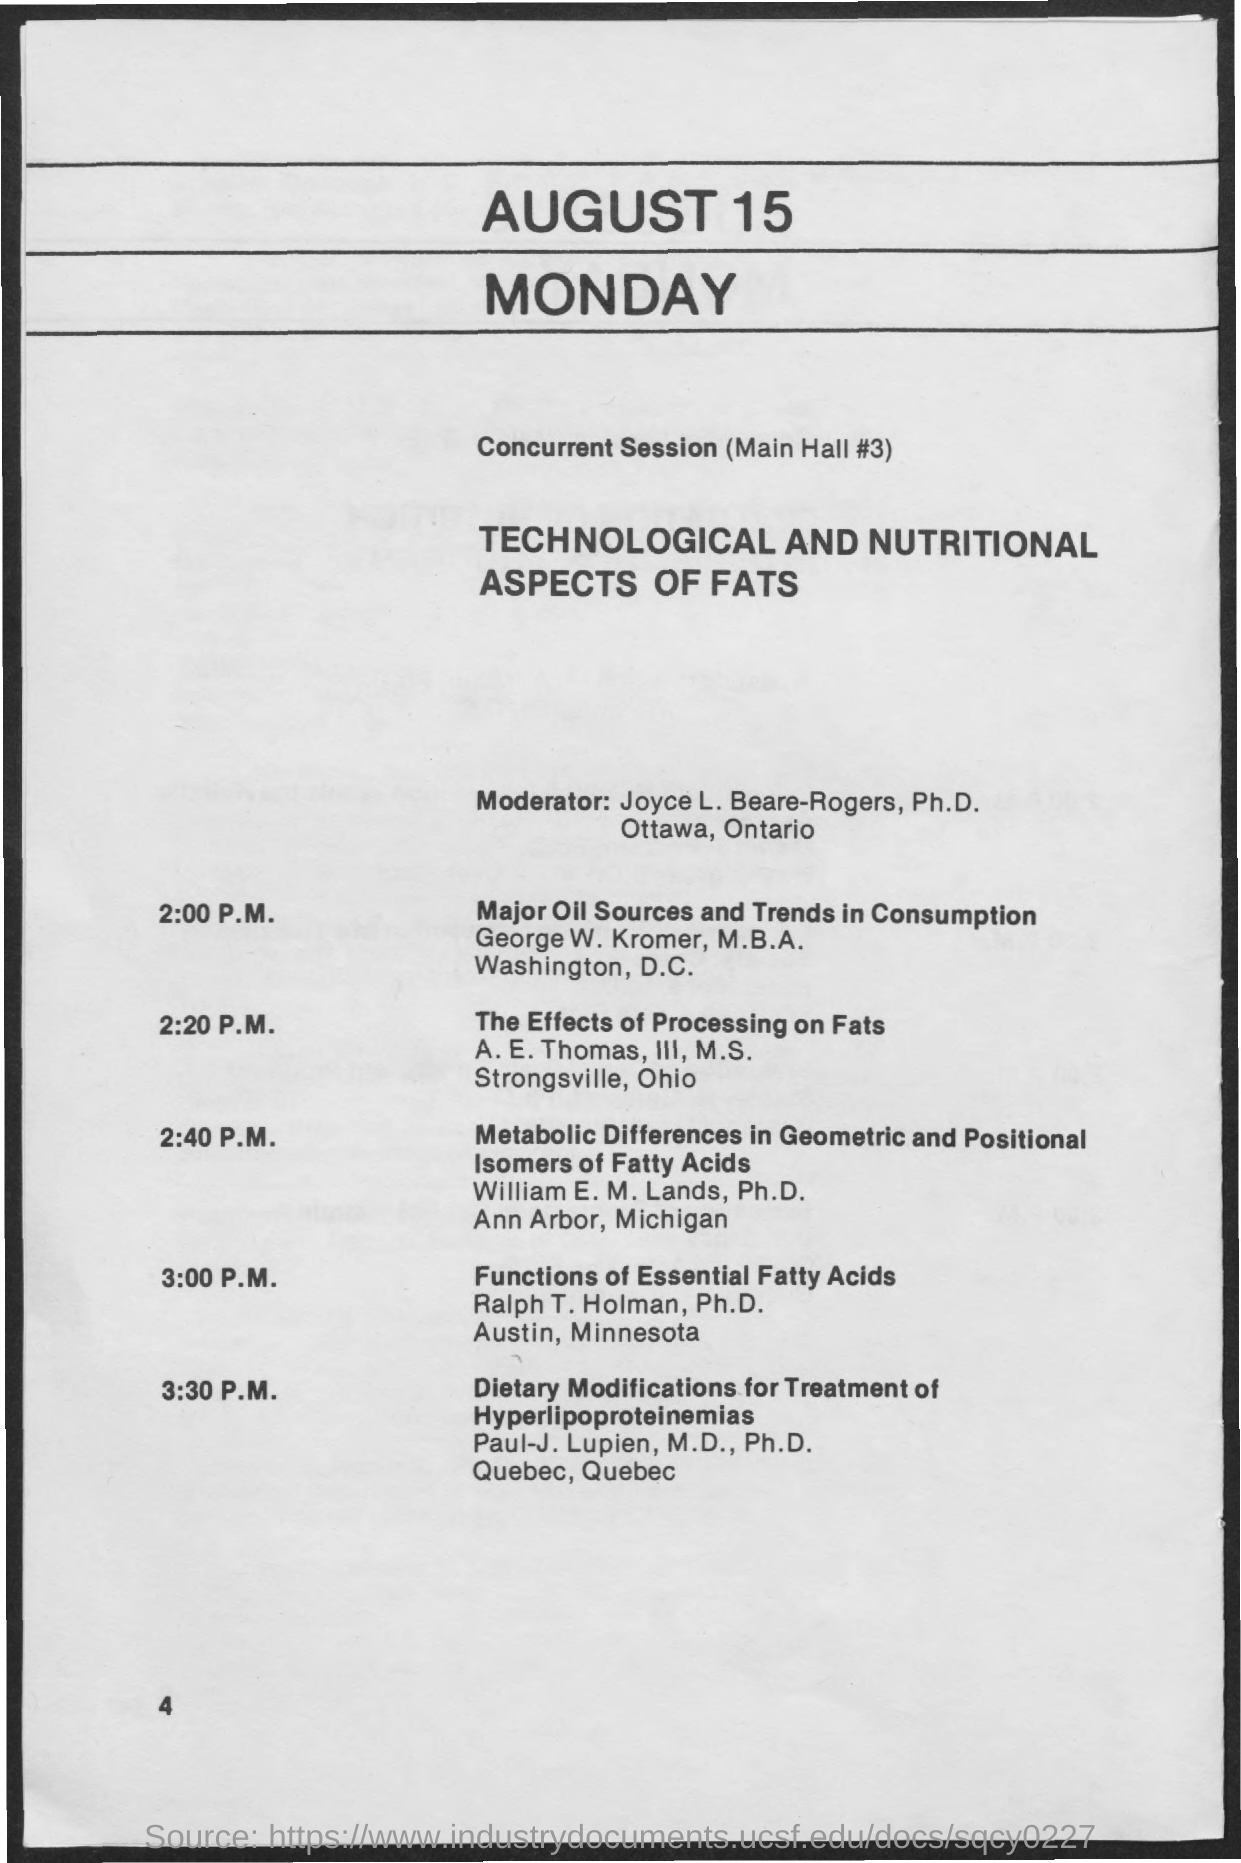List a handful of essential elements in this visual. The main hall is located in room number 3 where the concurrent session will take place. Ralph T. Holman, Ph.D., will be presenting a session on the functions of essential fatty acids. E. Thomas, III, M.S., is presenting the session on "The Effects of Processing on Fats. The session on "Major oil Sources and Trends in Consumption" is held at 2:00 P.M. The moderator for the sessions is Joyce L. Beare-Rogers, Ph.D. 